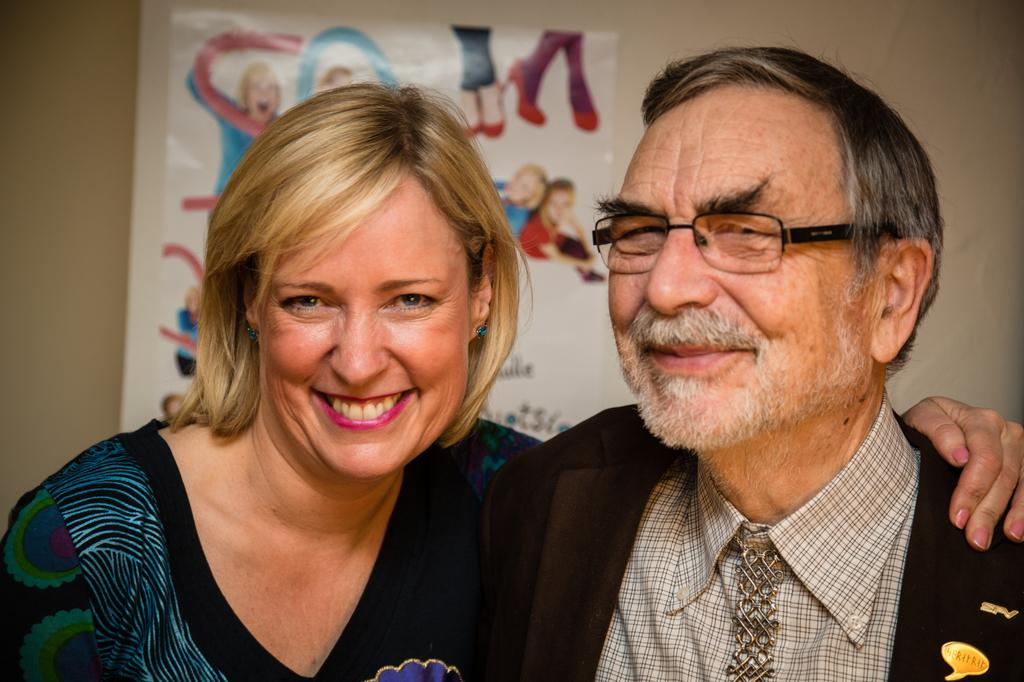Who is present in the image? There is a man and a woman in the image. What are the facial expressions of the people in the image? The man and the woman are both smiling in the image. What can be seen in the background of the image? There is a poster in the background of the image. How is the poster positioned in the image? The poster is attached to a wall in the image. What type of language is being spoken by the snow in the image? There is no snow present in the image, and therefore no language being spoken by it. Where is the faucet located in the image? There is no faucet present in the image. 